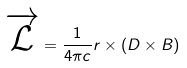<formula> <loc_0><loc_0><loc_500><loc_500>\overrightarrow { \mathcal { L } } = \frac { 1 } { 4 \pi c } r \times \left ( D \times B \right )</formula> 